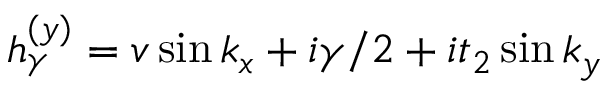<formula> <loc_0><loc_0><loc_500><loc_500>h _ { \gamma } ^ { ( y ) } = v \sin k _ { x } + i \gamma / 2 + i t _ { 2 } \sin k _ { y }</formula> 